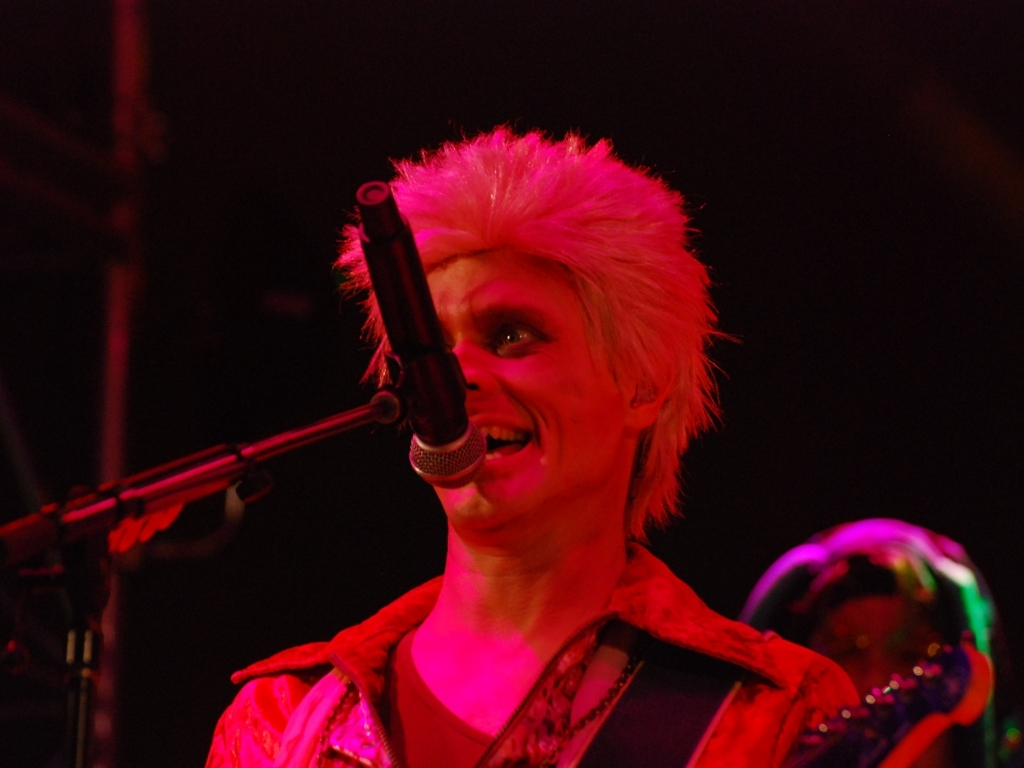Can you describe the singer's style and what it might indicate about the music they perform? The singer's style, characterized by spiked, brightly colored hair and a flashy, metallic jacket, suggests a performance that's likely energetic and possibly rooted in genres like glam rock or punk. This flamboyant fashion often signifies a rebellious and exuberant stage presence. 